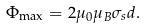Convert formula to latex. <formula><loc_0><loc_0><loc_500><loc_500>\Phi _ { \max } = 2 \mu _ { 0 } \mu _ { B } \sigma _ { s } d .</formula> 